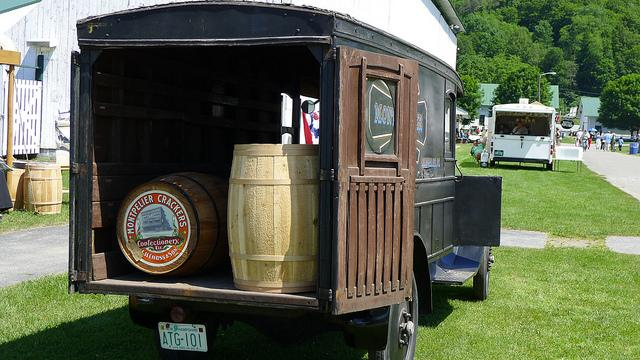What type of labeling is on the barrel? Please explain your reasoning. brand. It depicts a logo for a food company. 